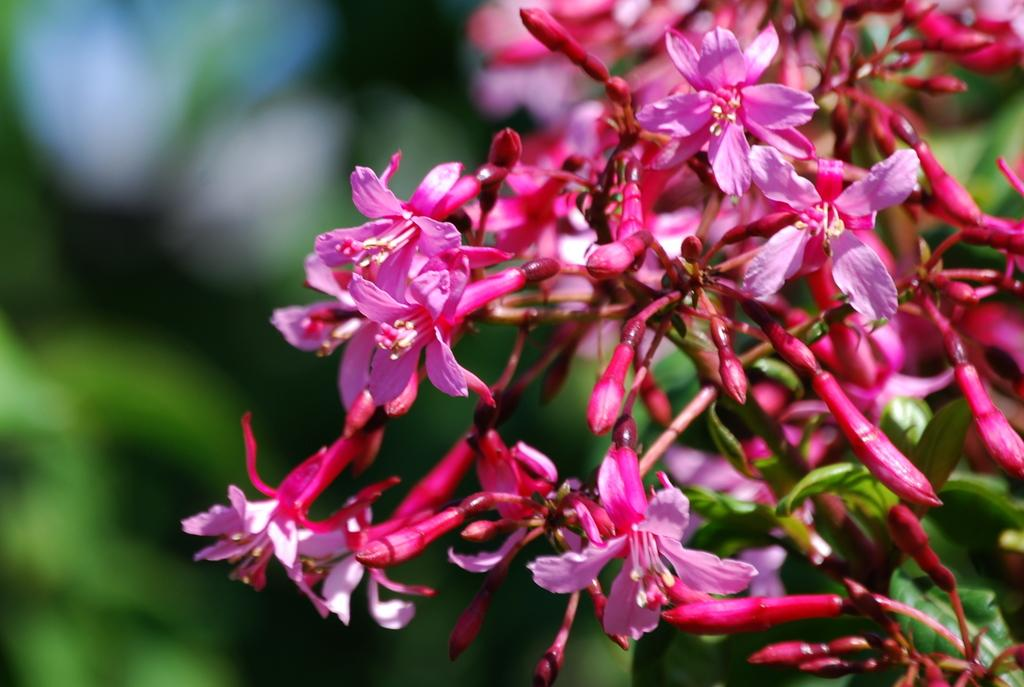What type of plants can be seen in the image? There are flowers and leaves in the image. Can you describe the appearance of the flowers? Unfortunately, the specific appearance of the flowers cannot be determined from the provided facts. What else is present in the image besides flowers and leaves? Based on the given facts, there is no other information about the image. What type of stone can be seen in the image? There is no mention of a stone in the provided facts, so it cannot be determined if a stone is present in the image. 